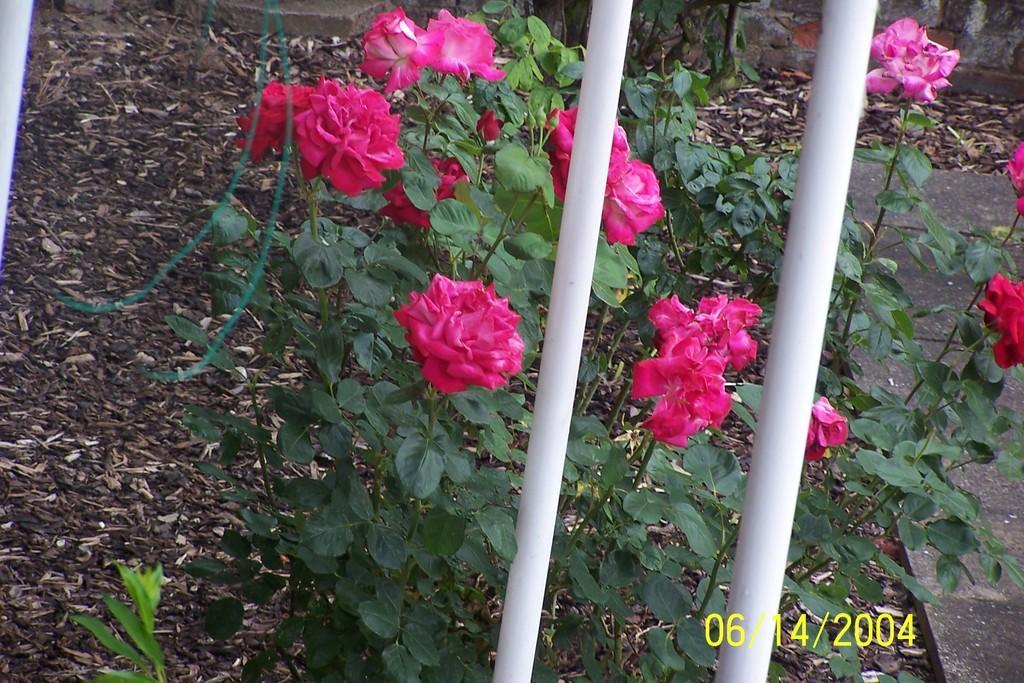Please provide a concise description of this image. In this picture there are pink color flowers on the plants. In the foreground there is a railing. At the bottom there are dried leaves and there is a road. At the back there is a wall. 